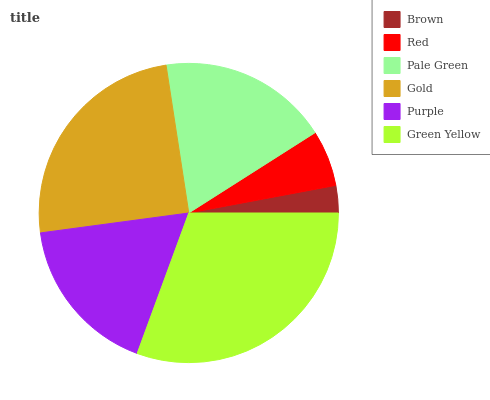Is Brown the minimum?
Answer yes or no. Yes. Is Green Yellow the maximum?
Answer yes or no. Yes. Is Red the minimum?
Answer yes or no. No. Is Red the maximum?
Answer yes or no. No. Is Red greater than Brown?
Answer yes or no. Yes. Is Brown less than Red?
Answer yes or no. Yes. Is Brown greater than Red?
Answer yes or no. No. Is Red less than Brown?
Answer yes or no. No. Is Pale Green the high median?
Answer yes or no. Yes. Is Purple the low median?
Answer yes or no. Yes. Is Red the high median?
Answer yes or no. No. Is Red the low median?
Answer yes or no. No. 